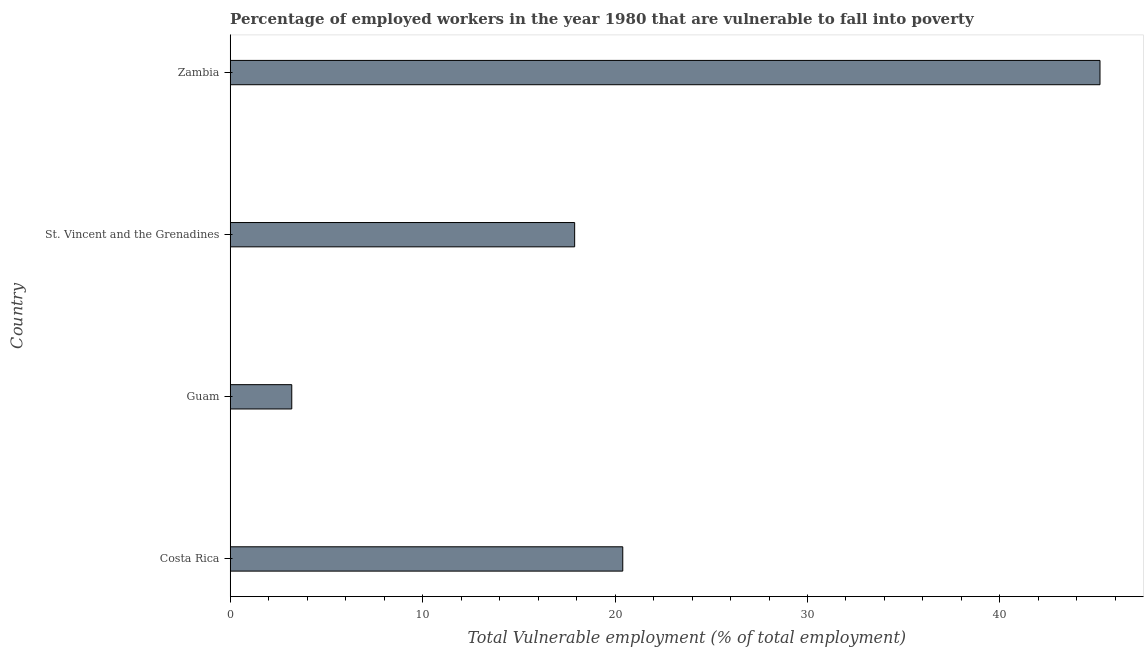Does the graph contain any zero values?
Ensure brevity in your answer.  No. Does the graph contain grids?
Give a very brief answer. No. What is the title of the graph?
Offer a very short reply. Percentage of employed workers in the year 1980 that are vulnerable to fall into poverty. What is the label or title of the X-axis?
Your answer should be very brief. Total Vulnerable employment (% of total employment). What is the total vulnerable employment in Zambia?
Your answer should be very brief. 45.2. Across all countries, what is the maximum total vulnerable employment?
Make the answer very short. 45.2. Across all countries, what is the minimum total vulnerable employment?
Your answer should be compact. 3.2. In which country was the total vulnerable employment maximum?
Provide a succinct answer. Zambia. In which country was the total vulnerable employment minimum?
Your response must be concise. Guam. What is the sum of the total vulnerable employment?
Make the answer very short. 86.7. What is the difference between the total vulnerable employment in St. Vincent and the Grenadines and Zambia?
Keep it short and to the point. -27.3. What is the average total vulnerable employment per country?
Give a very brief answer. 21.68. What is the median total vulnerable employment?
Your response must be concise. 19.15. What is the ratio of the total vulnerable employment in Costa Rica to that in Zambia?
Offer a very short reply. 0.45. Is the difference between the total vulnerable employment in Guam and Zambia greater than the difference between any two countries?
Offer a very short reply. Yes. What is the difference between the highest and the second highest total vulnerable employment?
Make the answer very short. 24.8. Is the sum of the total vulnerable employment in St. Vincent and the Grenadines and Zambia greater than the maximum total vulnerable employment across all countries?
Ensure brevity in your answer.  Yes. What is the difference between the highest and the lowest total vulnerable employment?
Your response must be concise. 42. How many bars are there?
Give a very brief answer. 4. Are the values on the major ticks of X-axis written in scientific E-notation?
Your response must be concise. No. What is the Total Vulnerable employment (% of total employment) of Costa Rica?
Make the answer very short. 20.4. What is the Total Vulnerable employment (% of total employment) in Guam?
Offer a very short reply. 3.2. What is the Total Vulnerable employment (% of total employment) in St. Vincent and the Grenadines?
Your answer should be compact. 17.9. What is the Total Vulnerable employment (% of total employment) of Zambia?
Provide a succinct answer. 45.2. What is the difference between the Total Vulnerable employment (% of total employment) in Costa Rica and Guam?
Keep it short and to the point. 17.2. What is the difference between the Total Vulnerable employment (% of total employment) in Costa Rica and Zambia?
Provide a short and direct response. -24.8. What is the difference between the Total Vulnerable employment (% of total employment) in Guam and St. Vincent and the Grenadines?
Keep it short and to the point. -14.7. What is the difference between the Total Vulnerable employment (% of total employment) in Guam and Zambia?
Give a very brief answer. -42. What is the difference between the Total Vulnerable employment (% of total employment) in St. Vincent and the Grenadines and Zambia?
Keep it short and to the point. -27.3. What is the ratio of the Total Vulnerable employment (% of total employment) in Costa Rica to that in Guam?
Ensure brevity in your answer.  6.38. What is the ratio of the Total Vulnerable employment (% of total employment) in Costa Rica to that in St. Vincent and the Grenadines?
Your response must be concise. 1.14. What is the ratio of the Total Vulnerable employment (% of total employment) in Costa Rica to that in Zambia?
Your answer should be compact. 0.45. What is the ratio of the Total Vulnerable employment (% of total employment) in Guam to that in St. Vincent and the Grenadines?
Your answer should be compact. 0.18. What is the ratio of the Total Vulnerable employment (% of total employment) in Guam to that in Zambia?
Make the answer very short. 0.07. What is the ratio of the Total Vulnerable employment (% of total employment) in St. Vincent and the Grenadines to that in Zambia?
Your answer should be very brief. 0.4. 